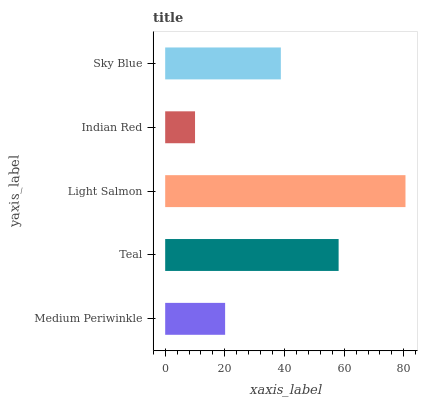Is Indian Red the minimum?
Answer yes or no. Yes. Is Light Salmon the maximum?
Answer yes or no. Yes. Is Teal the minimum?
Answer yes or no. No. Is Teal the maximum?
Answer yes or no. No. Is Teal greater than Medium Periwinkle?
Answer yes or no. Yes. Is Medium Periwinkle less than Teal?
Answer yes or no. Yes. Is Medium Periwinkle greater than Teal?
Answer yes or no. No. Is Teal less than Medium Periwinkle?
Answer yes or no. No. Is Sky Blue the high median?
Answer yes or no. Yes. Is Sky Blue the low median?
Answer yes or no. Yes. Is Light Salmon the high median?
Answer yes or no. No. Is Medium Periwinkle the low median?
Answer yes or no. No. 